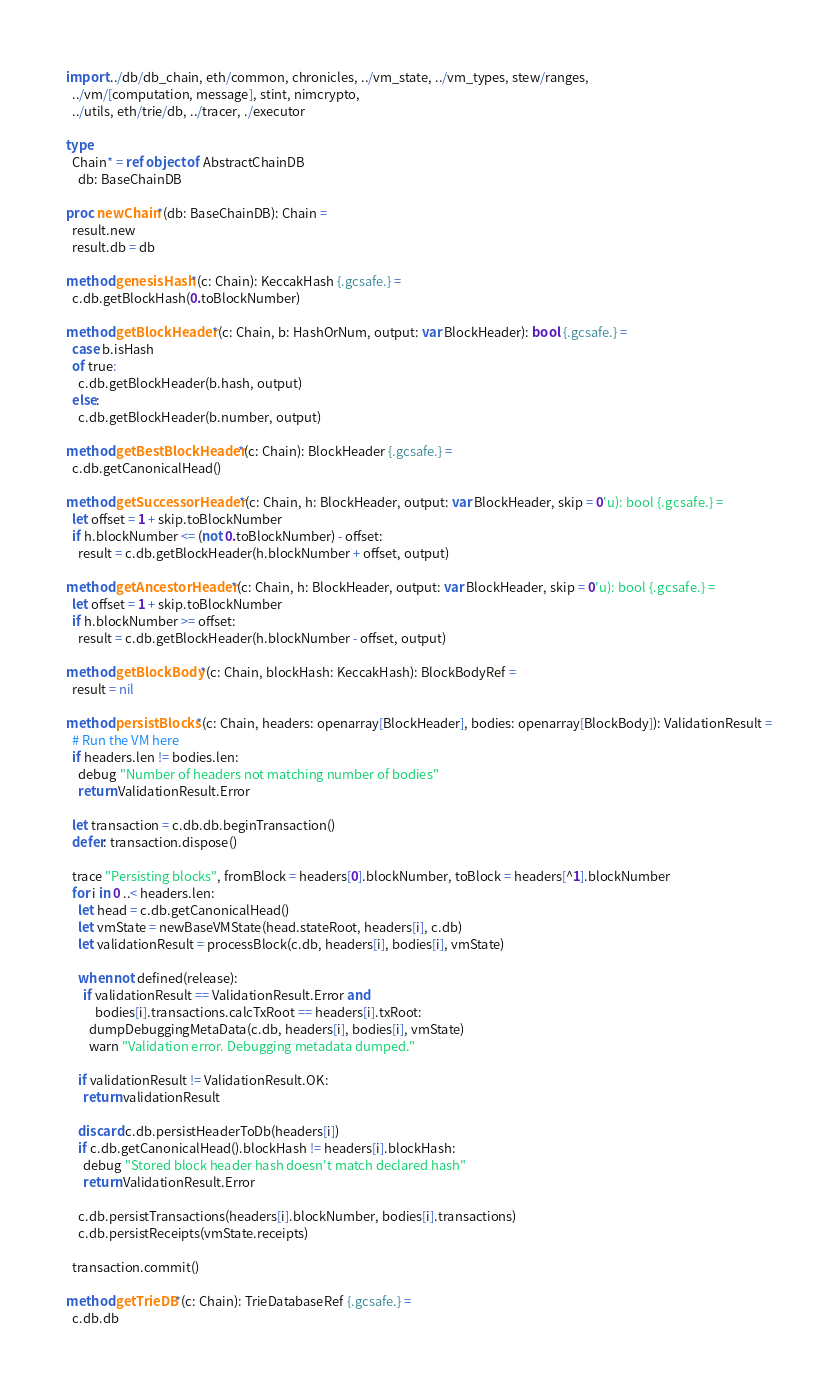<code> <loc_0><loc_0><loc_500><loc_500><_Nim_>import ../db/db_chain, eth/common, chronicles, ../vm_state, ../vm_types, stew/ranges,
  ../vm/[computation, message], stint, nimcrypto,
  ../utils, eth/trie/db, ../tracer, ./executor

type
  Chain* = ref object of AbstractChainDB
    db: BaseChainDB

proc newChain*(db: BaseChainDB): Chain =
  result.new
  result.db = db

method genesisHash*(c: Chain): KeccakHash {.gcsafe.} =
  c.db.getBlockHash(0.toBlockNumber)

method getBlockHeader*(c: Chain, b: HashOrNum, output: var BlockHeader): bool {.gcsafe.} =
  case b.isHash
  of true:
    c.db.getBlockHeader(b.hash, output)
  else:
    c.db.getBlockHeader(b.number, output)

method getBestBlockHeader*(c: Chain): BlockHeader {.gcsafe.} =
  c.db.getCanonicalHead()

method getSuccessorHeader*(c: Chain, h: BlockHeader, output: var BlockHeader, skip = 0'u): bool {.gcsafe.} =
  let offset = 1 + skip.toBlockNumber
  if h.blockNumber <= (not 0.toBlockNumber) - offset:
    result = c.db.getBlockHeader(h.blockNumber + offset, output)

method getAncestorHeader*(c: Chain, h: BlockHeader, output: var BlockHeader, skip = 0'u): bool {.gcsafe.} =
  let offset = 1 + skip.toBlockNumber
  if h.blockNumber >= offset:
    result = c.db.getBlockHeader(h.blockNumber - offset, output)

method getBlockBody*(c: Chain, blockHash: KeccakHash): BlockBodyRef =
  result = nil

method persistBlocks*(c: Chain, headers: openarray[BlockHeader], bodies: openarray[BlockBody]): ValidationResult =
  # Run the VM here
  if headers.len != bodies.len:
    debug "Number of headers not matching number of bodies"
    return ValidationResult.Error

  let transaction = c.db.db.beginTransaction()
  defer: transaction.dispose()

  trace "Persisting blocks", fromBlock = headers[0].blockNumber, toBlock = headers[^1].blockNumber
  for i in 0 ..< headers.len:
    let head = c.db.getCanonicalHead()
    let vmState = newBaseVMState(head.stateRoot, headers[i], c.db)
    let validationResult = processBlock(c.db, headers[i], bodies[i], vmState)

    when not defined(release):
      if validationResult == ValidationResult.Error and
          bodies[i].transactions.calcTxRoot == headers[i].txRoot:
        dumpDebuggingMetaData(c.db, headers[i], bodies[i], vmState)
        warn "Validation error. Debugging metadata dumped."

    if validationResult != ValidationResult.OK:
      return validationResult

    discard c.db.persistHeaderToDb(headers[i])
    if c.db.getCanonicalHead().blockHash != headers[i].blockHash:
      debug "Stored block header hash doesn't match declared hash"
      return ValidationResult.Error

    c.db.persistTransactions(headers[i].blockNumber, bodies[i].transactions)
    c.db.persistReceipts(vmState.receipts)

  transaction.commit()

method getTrieDB*(c: Chain): TrieDatabaseRef {.gcsafe.} =
  c.db.db

</code> 